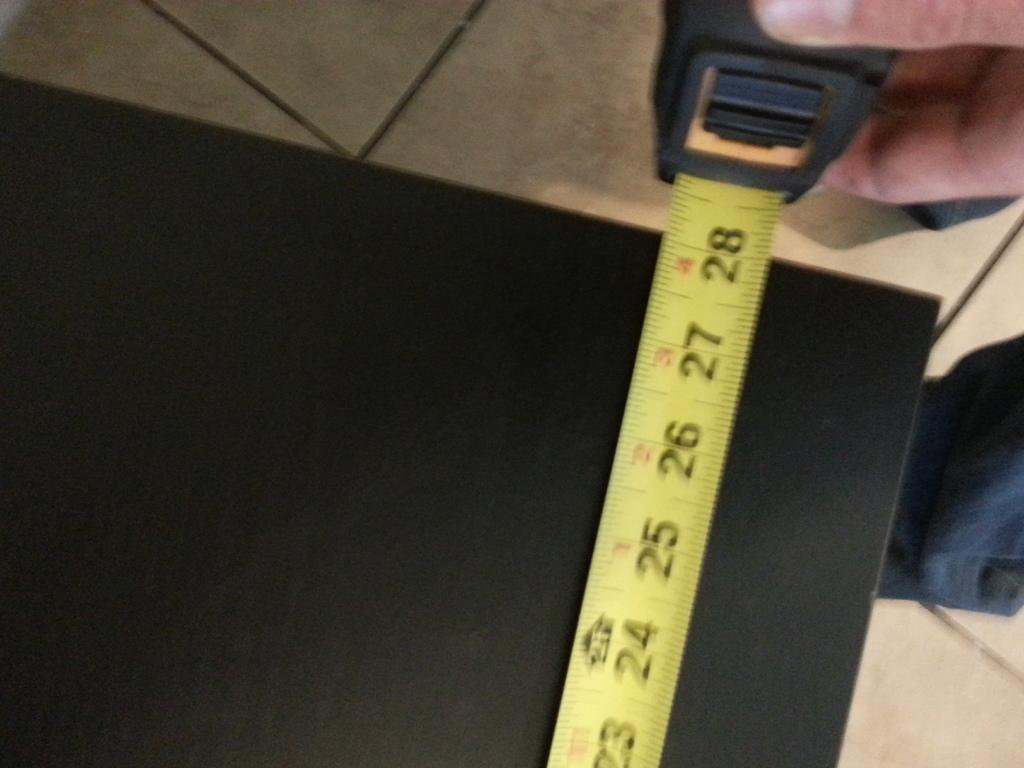Provide a one-sentence caption for the provided image. The tape measure shows the black table to be 28 inches in length. 